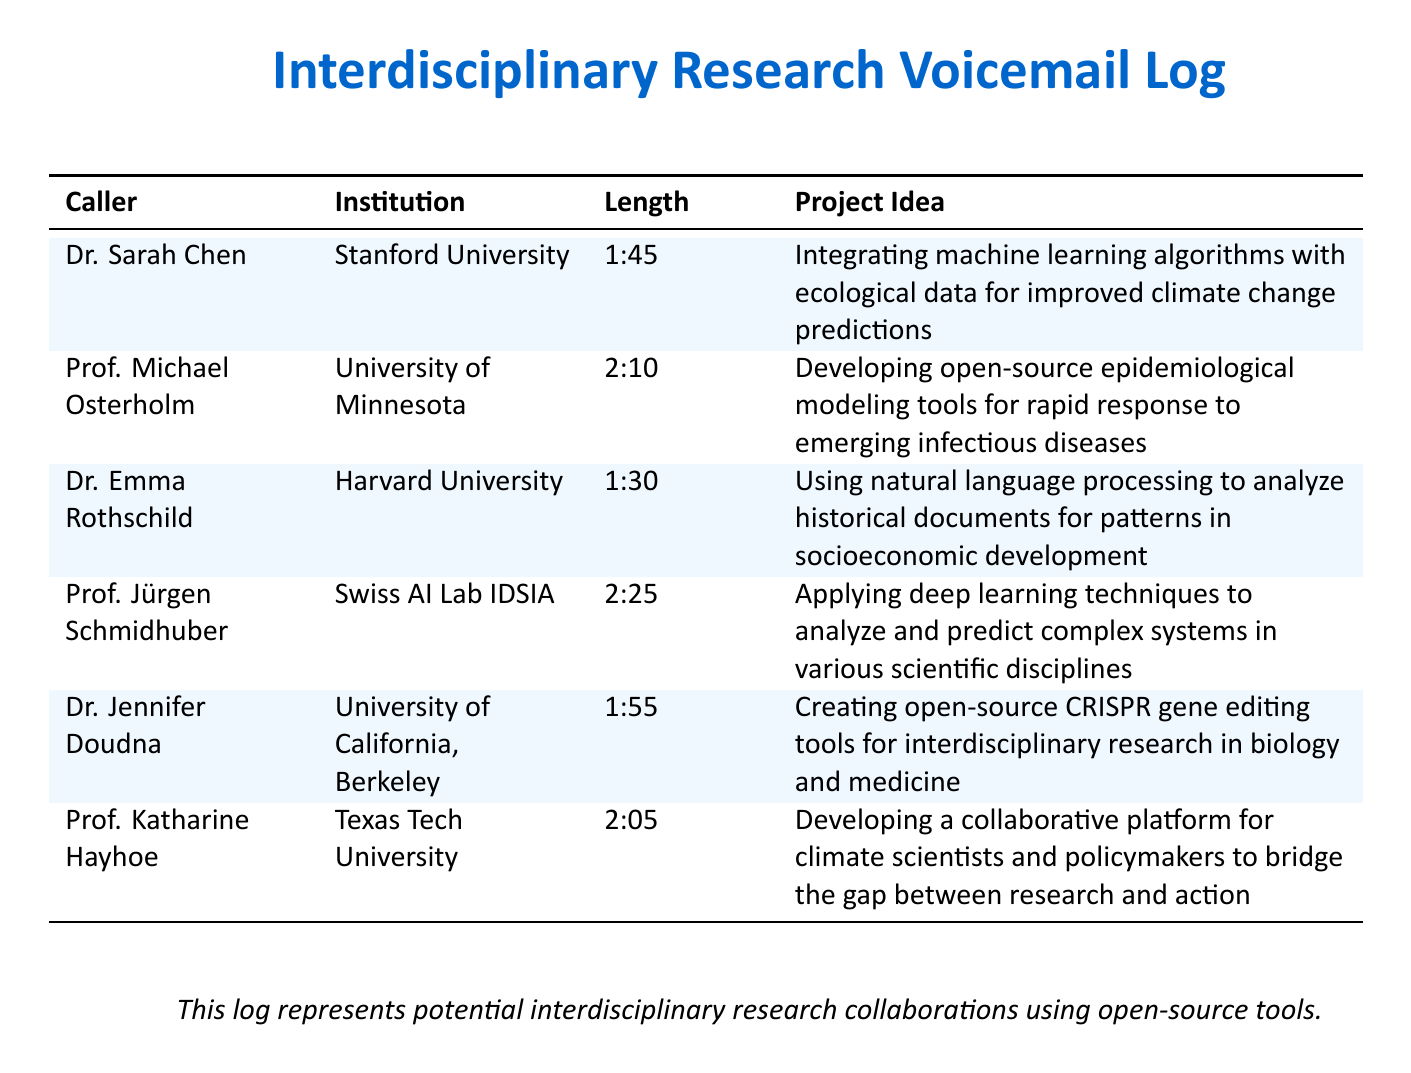What is the name of the caller from Stanford University? The caller from Stanford University is Dr. Sarah Chen, as indicated in the document.
Answer: Dr. Sarah Chen How long is Prof. Jürgen Schmidhuber's voicemail message? Prof. Jürgen Schmidhuber's voicemail message length is recorded in the document as 2:25.
Answer: 2:25 What is the project idea proposed by Dr. Jennifer Doudna? The project idea proposed by Dr. Jennifer Doudna is mentioned in the document as creating open-source CRISPR gene editing tools for interdisciplinary research in biology and medicine.
Answer: Creating open-source CRISPR gene editing tools Which institution is Prof. Katharine Hayhoe affiliated with? The document specifies that Prof. Katharine Hayhoe is affiliated with Texas Tech University.
Answer: Texas Tech University Which caller's project idea involves natural language processing? The caller discussing natural language processing is Dr. Emma Rothschild, as per the document's content.
Answer: Dr. Emma Rothschild What common theme can be found in the project ideas shared? The common theme among the project ideas is the use of open-source tools to address various interdisciplinary research challenges.
Answer: Use of open-source tools Who called to discuss epidemiological modeling tools? Prof. Michael Osterholm is identified in the document as the caller discussing epidemiological modeling tools.
Answer: Prof. Michael Osterholm What are the voicemail messages primarily focused on? The voicemail messages primarily discuss potential interdisciplinary research projects, as outlined in the document.
Answer: Interdisciplinary research projects How many callers are from the University of California? According to the document, there is one caller from the University of California, Berkeley.
Answer: One 